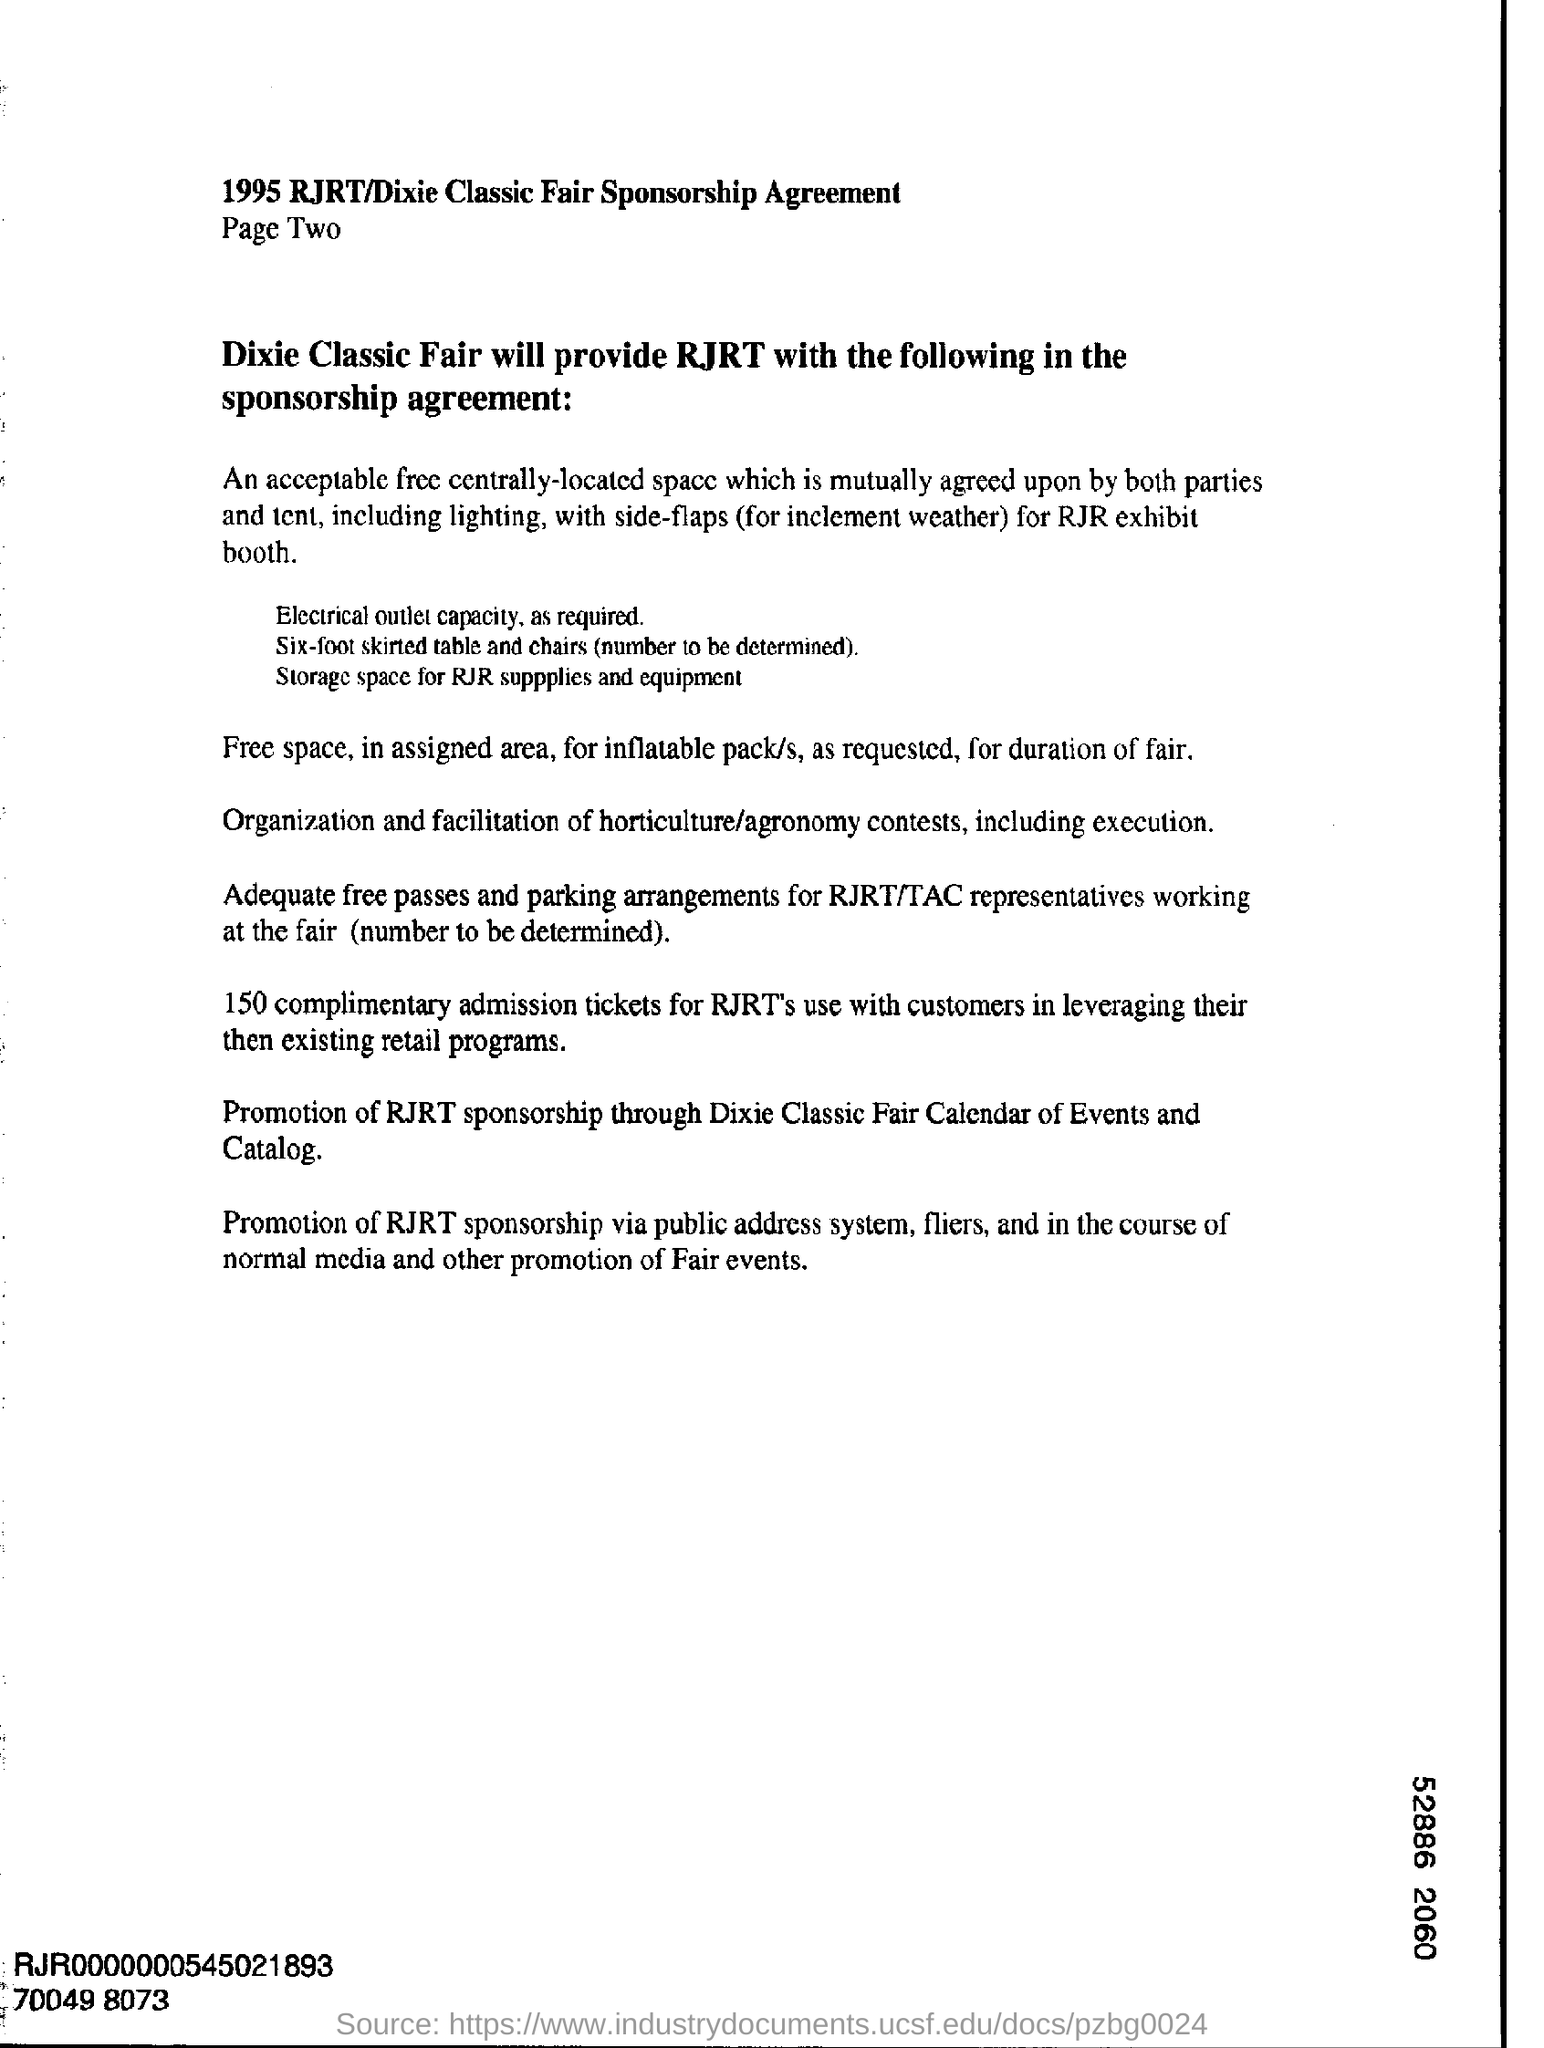Specify some key components in this picture. The digit shown at the bottom right corner of the number "52886 2060" is 6. 